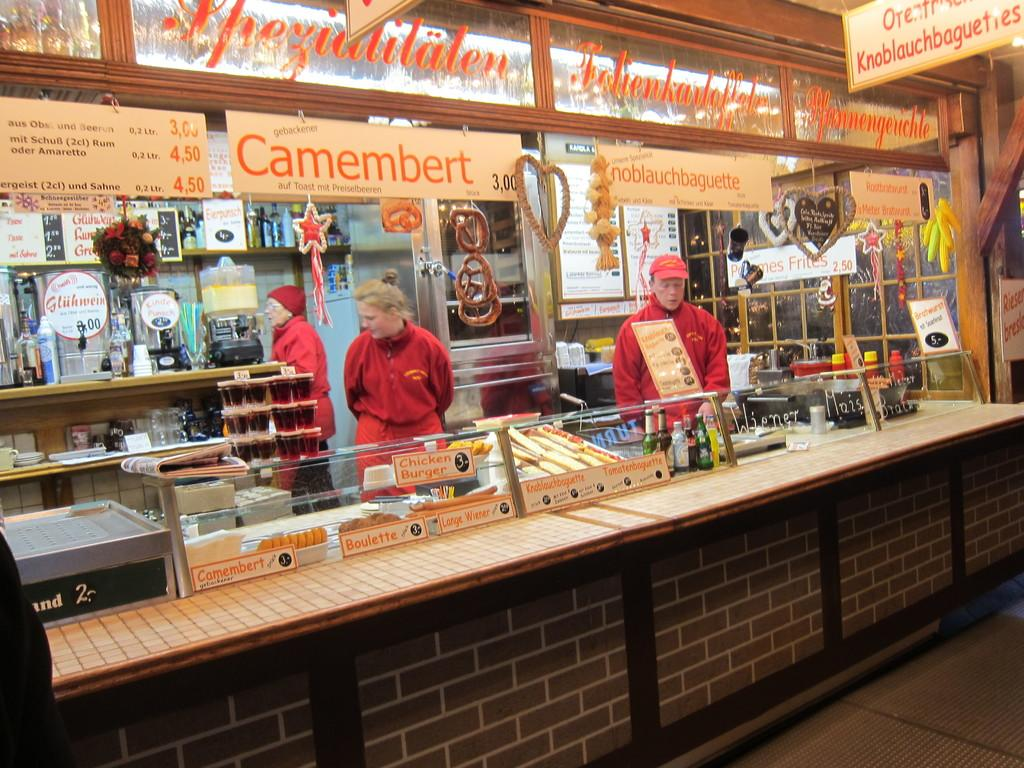Provide a one-sentence caption for the provided image. Person standing behind a stall that says "noblauchbaguette" on it. 